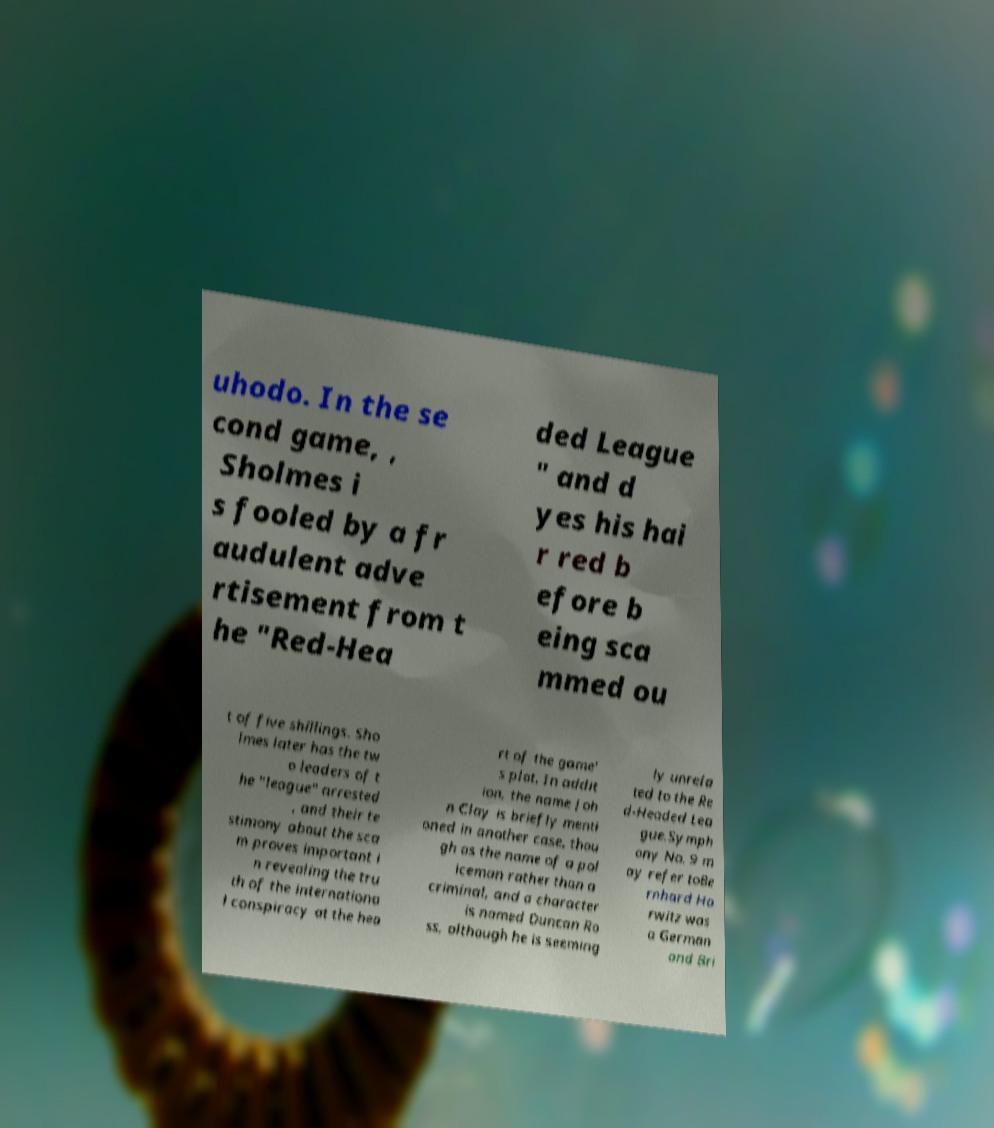Could you extract and type out the text from this image? uhodo. In the se cond game, , Sholmes i s fooled by a fr audulent adve rtisement from t he "Red-Hea ded League " and d yes his hai r red b efore b eing sca mmed ou t of five shillings. Sho lmes later has the tw o leaders of t he "league" arrested , and their te stimony about the sca m proves important i n revealing the tru th of the internationa l conspiracy at the hea rt of the game' s plot. In addit ion, the name Joh n Clay is briefly menti oned in another case, thou gh as the name of a pol iceman rather than a criminal, and a character is named Duncan Ro ss, although he is seeming ly unrela ted to the Re d-Headed Lea gue.Symph ony No. 9 m ay refer toBe rnhard Ho rwitz was a German and Bri 